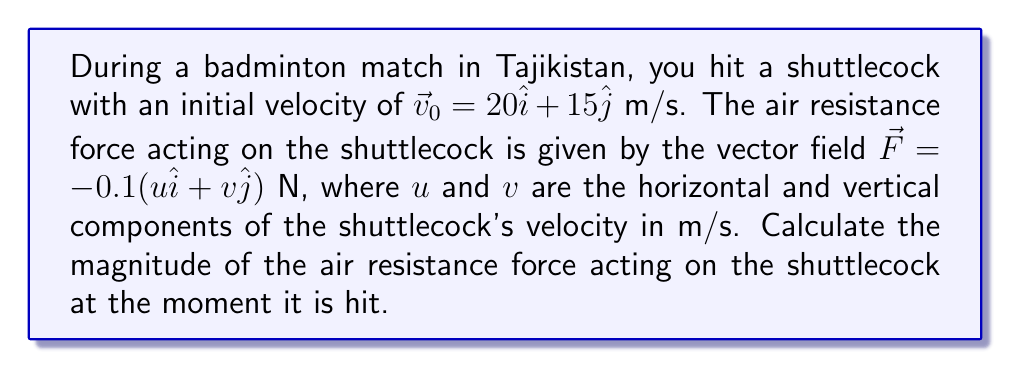Can you solve this math problem? Let's approach this step-by-step:

1) We are given the initial velocity vector:
   $$\vec{v}_0 = 20\hat{i} + 15\hat{j}$$ m/s

2) The air resistance force is given by the vector field:
   $$\vec{F} = -0.1(u\hat{i} + v\hat{j})$$ N

3) At the moment the shuttlecock is hit, its velocity components are:
   $u = 20$ m/s (horizontal component)
   $v = 15$ m/s (vertical component)

4) Substituting these values into the force equation:
   $$\vec{F} = -0.1(20\hat{i} + 15\hat{j})$$ N

5) Simplifying:
   $$\vec{F} = -2\hat{i} - 1.5\hat{j}$$ N

6) To find the magnitude of this force vector, we use the Pythagorean theorem:
   $$|\vec{F}| = \sqrt{(-2)^2 + (-1.5)^2}$$ N

7) Calculating:
   $$|\vec{F}| = \sqrt{4 + 2.25} = \sqrt{6.25} = 2.5$$ N

Therefore, the magnitude of the air resistance force at the moment the shuttlecock is hit is 2.5 N.
Answer: 2.5 N 